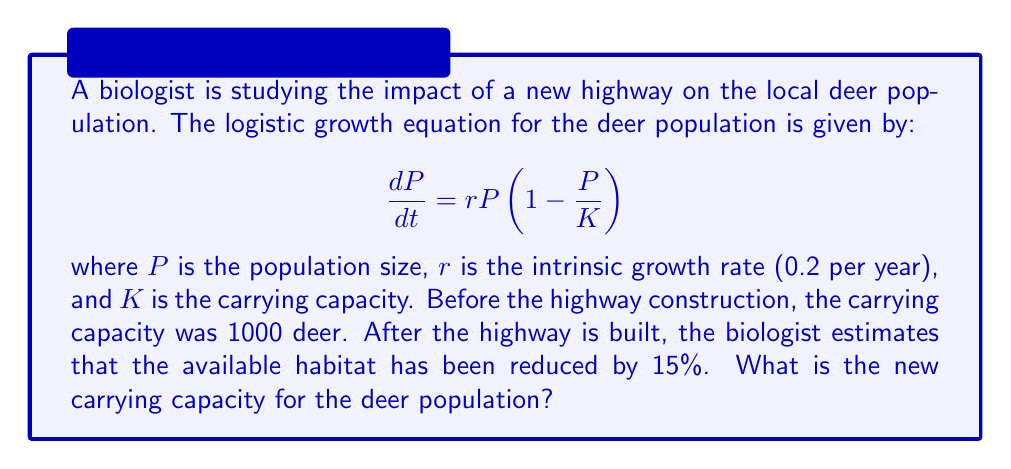Solve this math problem. To solve this problem, we need to follow these steps:

1. Understand the given information:
   - Initial carrying capacity (K) = 1000 deer
   - Habitat reduction = 15%

2. Calculate the percentage of habitat remaining:
   100% - 15% = 85% or 0.85

3. Calculate the new carrying capacity:
   New K = Original K × Remaining habitat percentage
   New K = 1000 × 0.85

4. Perform the calculation:
   New K = 850 deer

The logistic growth equation remains the same, but the carrying capacity (K) has changed due to the habitat reduction caused by the highway construction. This new carrying capacity represents the maximum number of deer that can be sustainably supported in the reduced habitat.
Answer: The new carrying capacity for the deer population after the highway construction is 850 deer. 